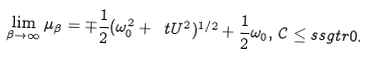<formula> <loc_0><loc_0><loc_500><loc_500>\lim _ { \beta \to \infty } \mu _ { \beta } = \mp \frac { 1 } { 2 } ( \omega _ { 0 } ^ { 2 } + \ t { U } ^ { 2 } ) ^ { 1 / 2 } + \frac { 1 } { 2 } \omega _ { 0 } , \, \mathcal { C } \leq s s g t r 0 .</formula> 